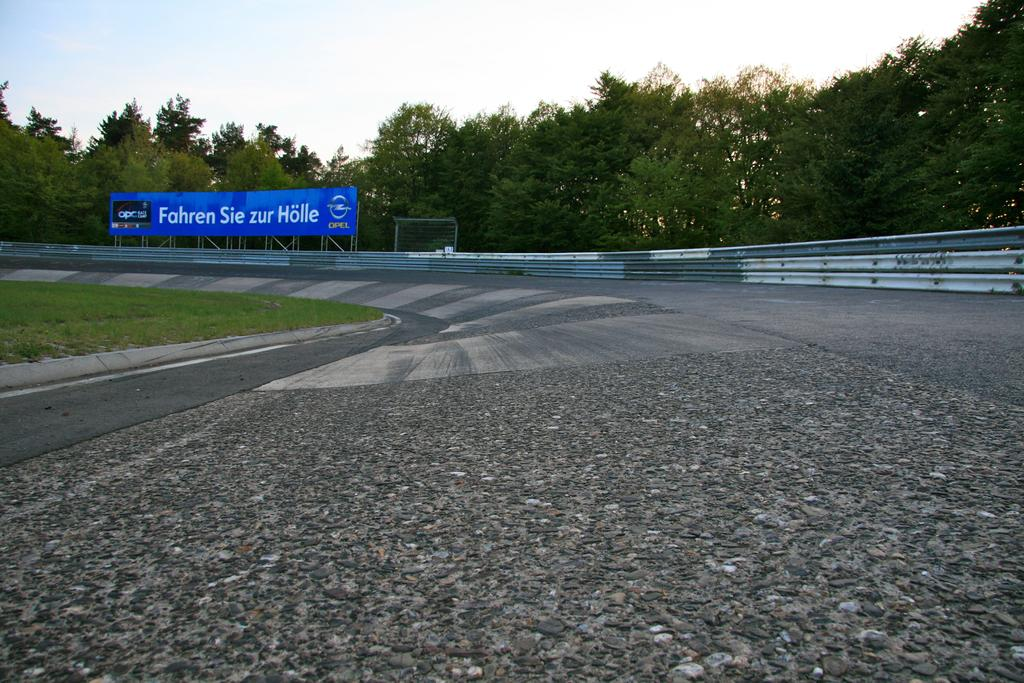<image>
Summarize the visual content of the image. a sign saying fahren sie zur holle is shown on the road 